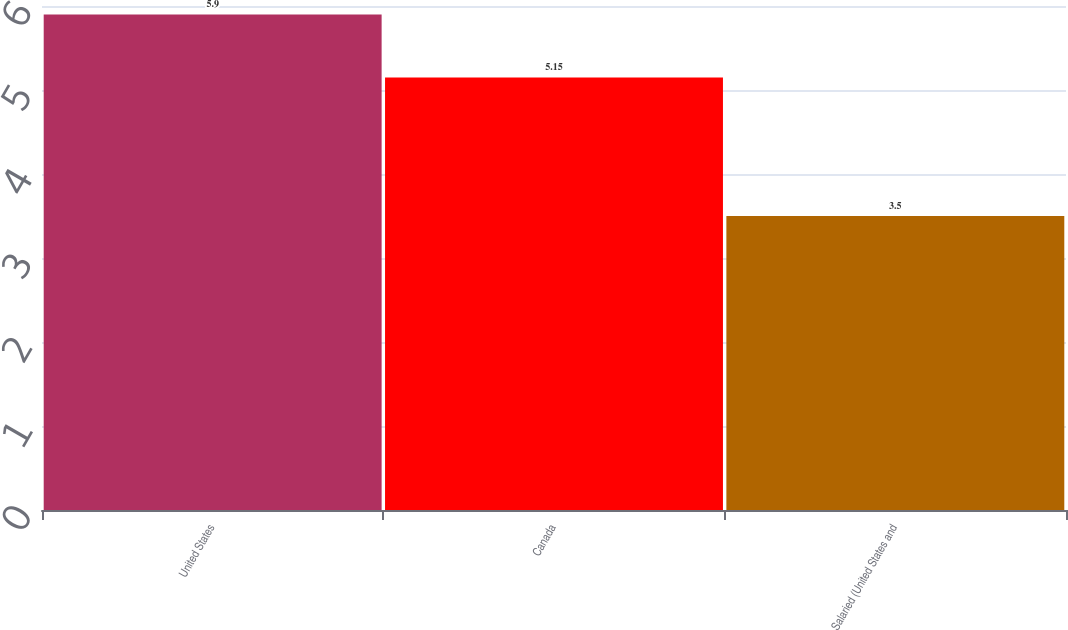Convert chart to OTSL. <chart><loc_0><loc_0><loc_500><loc_500><bar_chart><fcel>United States<fcel>Canada<fcel>Salaried (United States and<nl><fcel>5.9<fcel>5.15<fcel>3.5<nl></chart> 